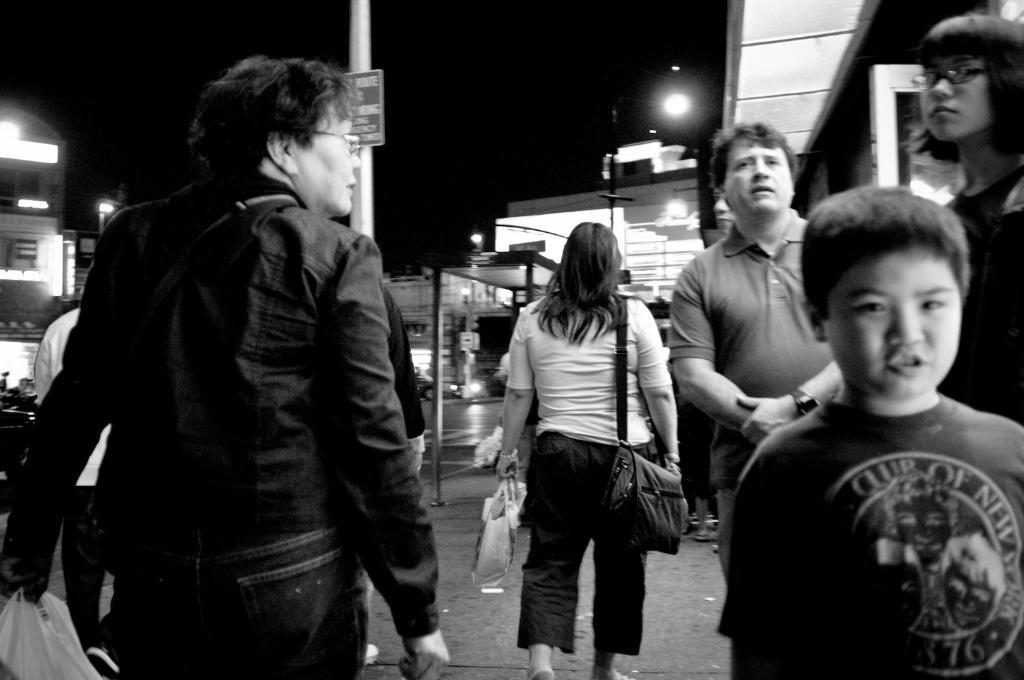What are the people in the image doing? The persons in the image are standing on the street. What can be seen in the background of the image? There are buildings, street poles, street lights, and the sky visible in the background of the image. How many spiders are crawling on the buildings in the image? There are no spiders visible in the image; only buildings, street poles, street lights, and the sky are present. What type of map is being used by the persons in the image? There is no map present in the image; the persons are simply standing on the street. 